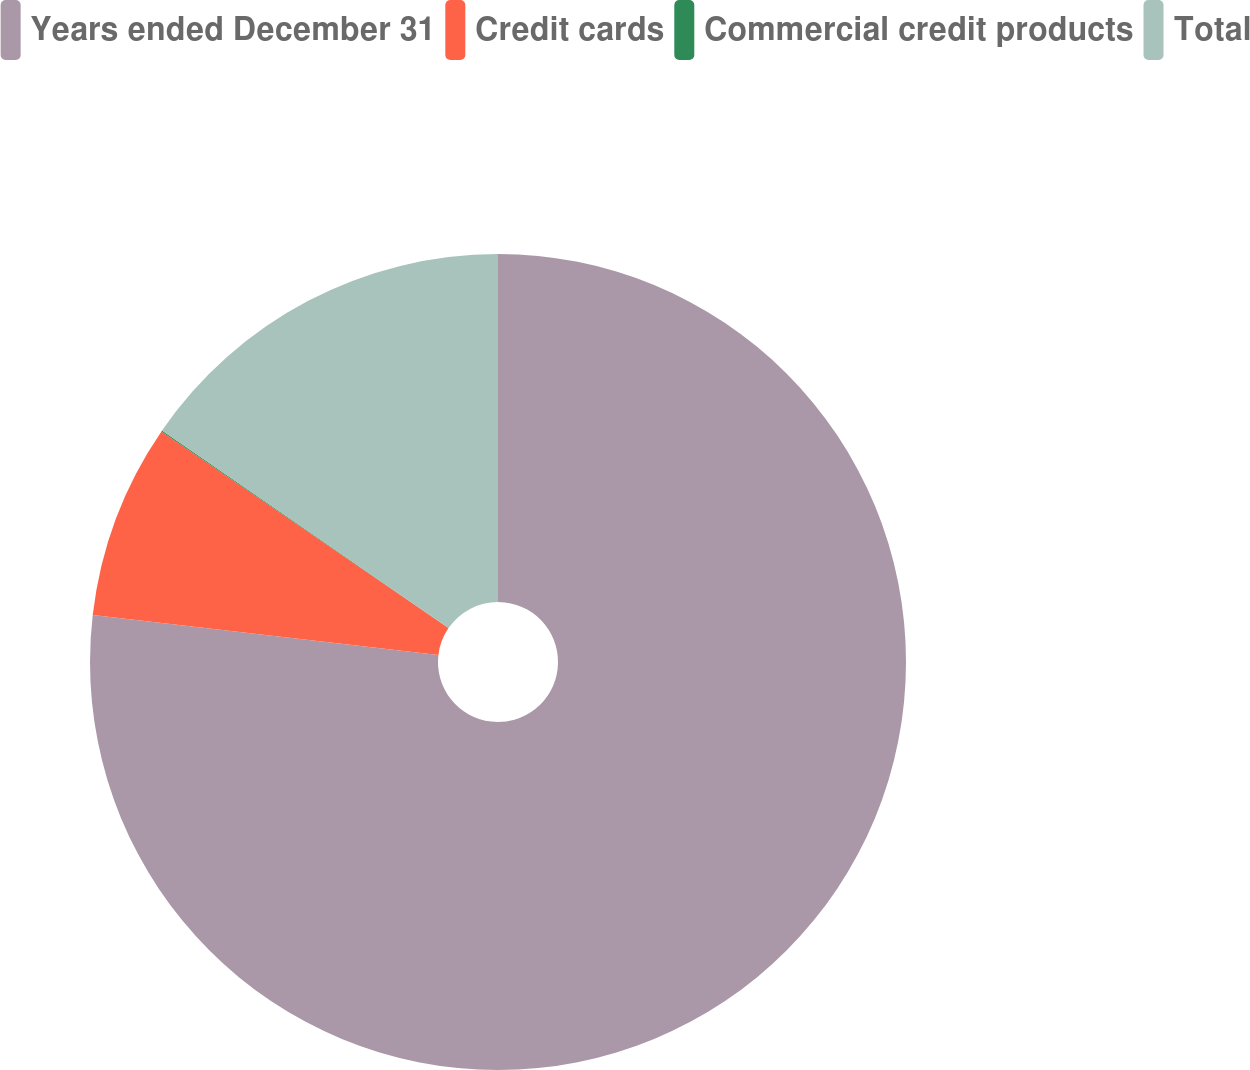Convert chart. <chart><loc_0><loc_0><loc_500><loc_500><pie_chart><fcel>Years ended December 31<fcel>Credit cards<fcel>Commercial credit products<fcel>Total<nl><fcel>76.84%<fcel>7.72%<fcel>0.04%<fcel>15.4%<nl></chart> 